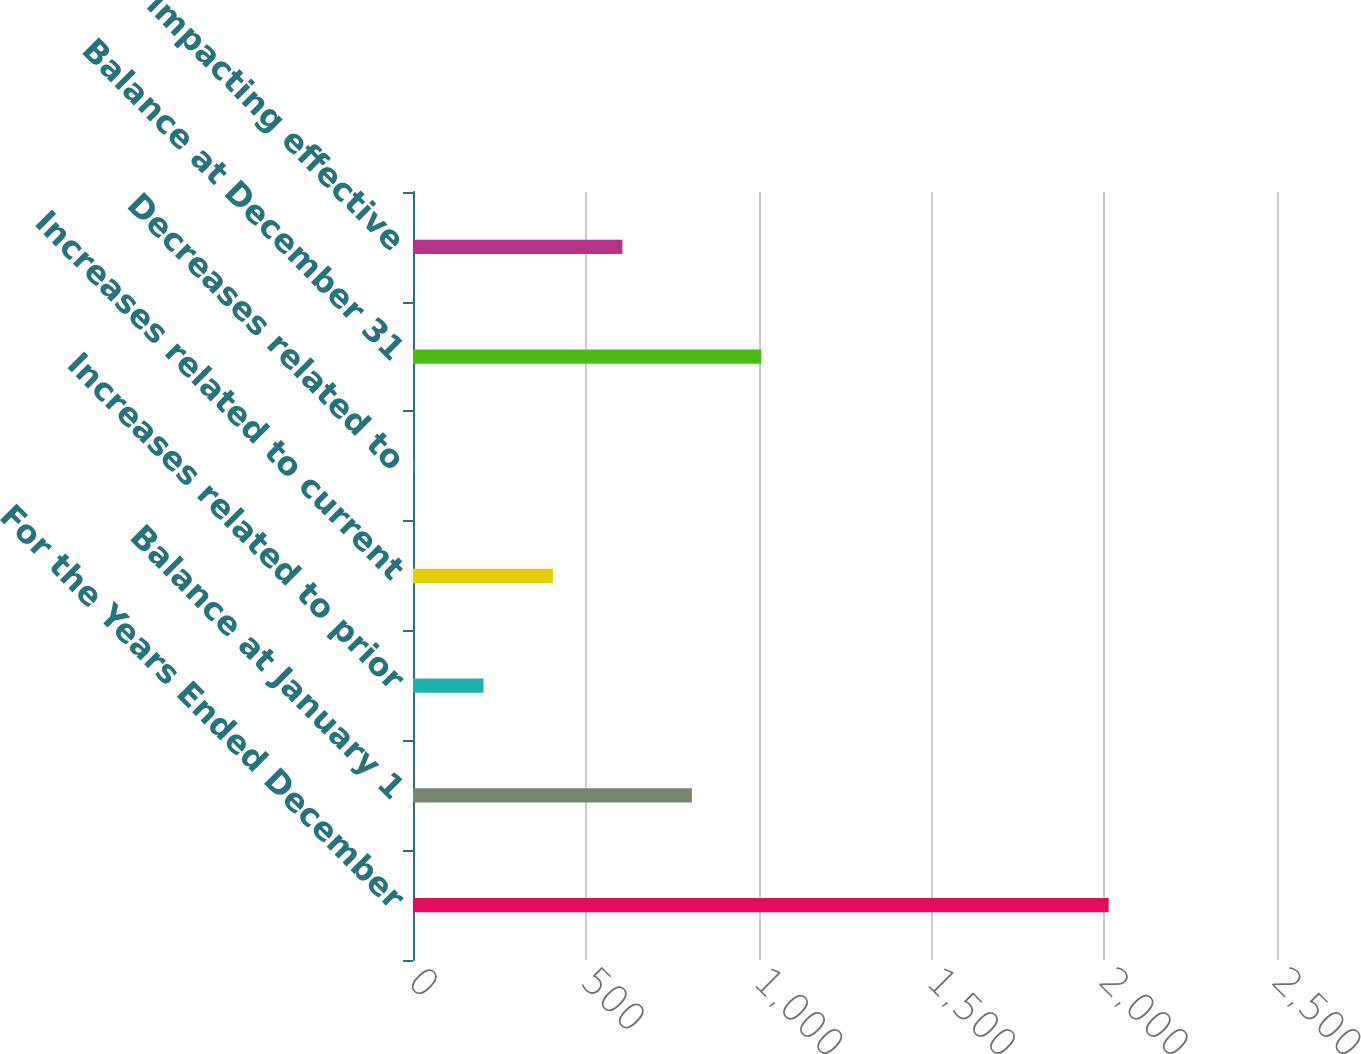Convert chart to OTSL. <chart><loc_0><loc_0><loc_500><loc_500><bar_chart><fcel>For the Years Ended December<fcel>Balance at January 1<fcel>Increases related to prior<fcel>Increases related to current<fcel>Decreases related to<fcel>Balance at December 31<fcel>Amounts impacting effective<nl><fcel>2013<fcel>806.94<fcel>203.91<fcel>404.92<fcel>2.9<fcel>1007.95<fcel>605.93<nl></chart> 